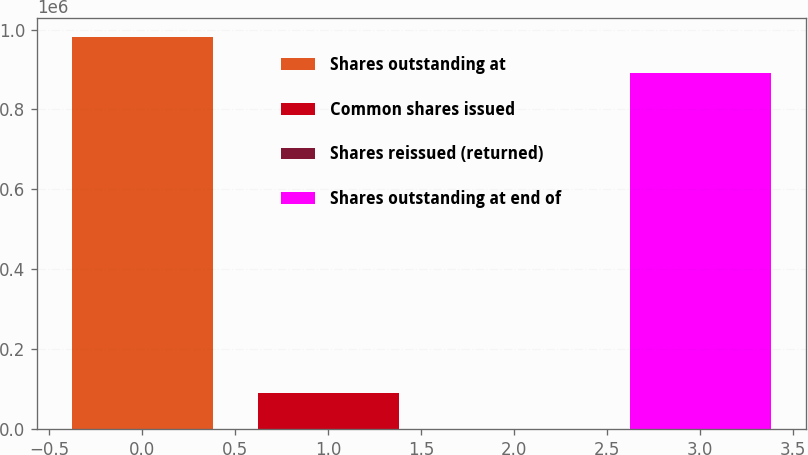Convert chart to OTSL. <chart><loc_0><loc_0><loc_500><loc_500><bar_chart><fcel>Shares outstanding at<fcel>Common shares issued<fcel>Shares reissued (returned)<fcel>Shares outstanding at end of<nl><fcel>980450<fcel>90287.9<fcel>562<fcel>890724<nl></chart> 